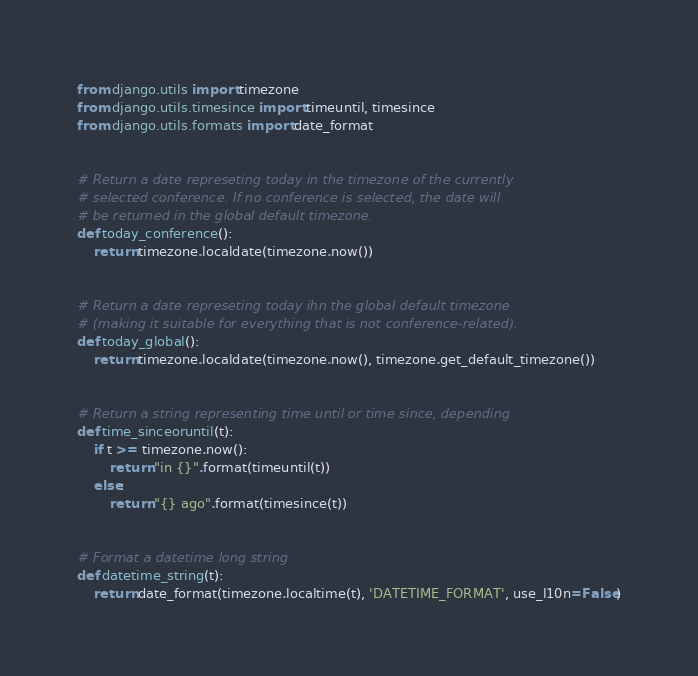<code> <loc_0><loc_0><loc_500><loc_500><_Python_>from django.utils import timezone
from django.utils.timesince import timeuntil, timesince
from django.utils.formats import date_format


# Return a date represeting today in the timezone of the currently
# selected conference. If no conference is selected, the date will
# be returned in the global default timezone.
def today_conference():
    return timezone.localdate(timezone.now())


# Return a date represeting today ihn the global default timezone
# (making it suitable for everything that is not conference-related).
def today_global():
    return timezone.localdate(timezone.now(), timezone.get_default_timezone())


# Return a string representing time until or time since, depending
def time_sinceoruntil(t):
    if t >= timezone.now():
        return "in {}".format(timeuntil(t))
    else:
        return "{} ago".format(timesince(t))


# Format a datetime long string
def datetime_string(t):
    return date_format(timezone.localtime(t), 'DATETIME_FORMAT', use_l10n=False)
</code> 